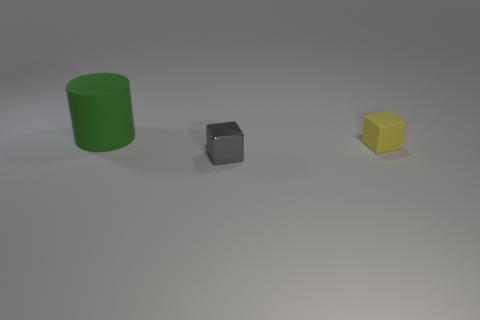Is the lighting coming from a particular direction in the image? Yes, the lighting in the image appears to be coming from above and slightly to the front of the objects, creating subtle shadows behind them towards the bottom right of the scene. 